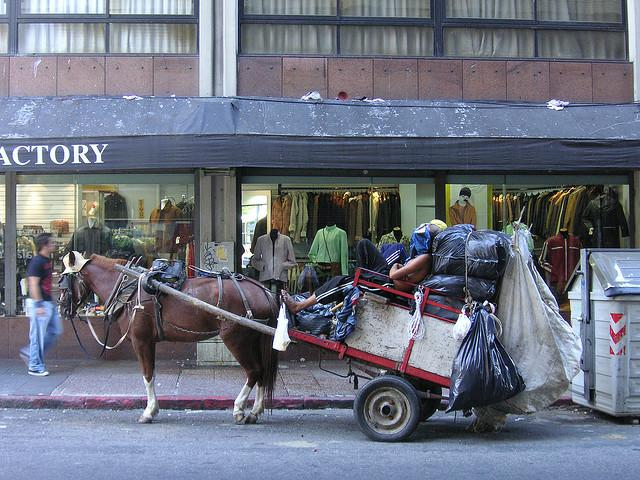What item here makes the horse go forward focusing? Please explain your reasoning. blinders. They put shades on the side of the horse's eyes so they don't get startled by something off to the side. 